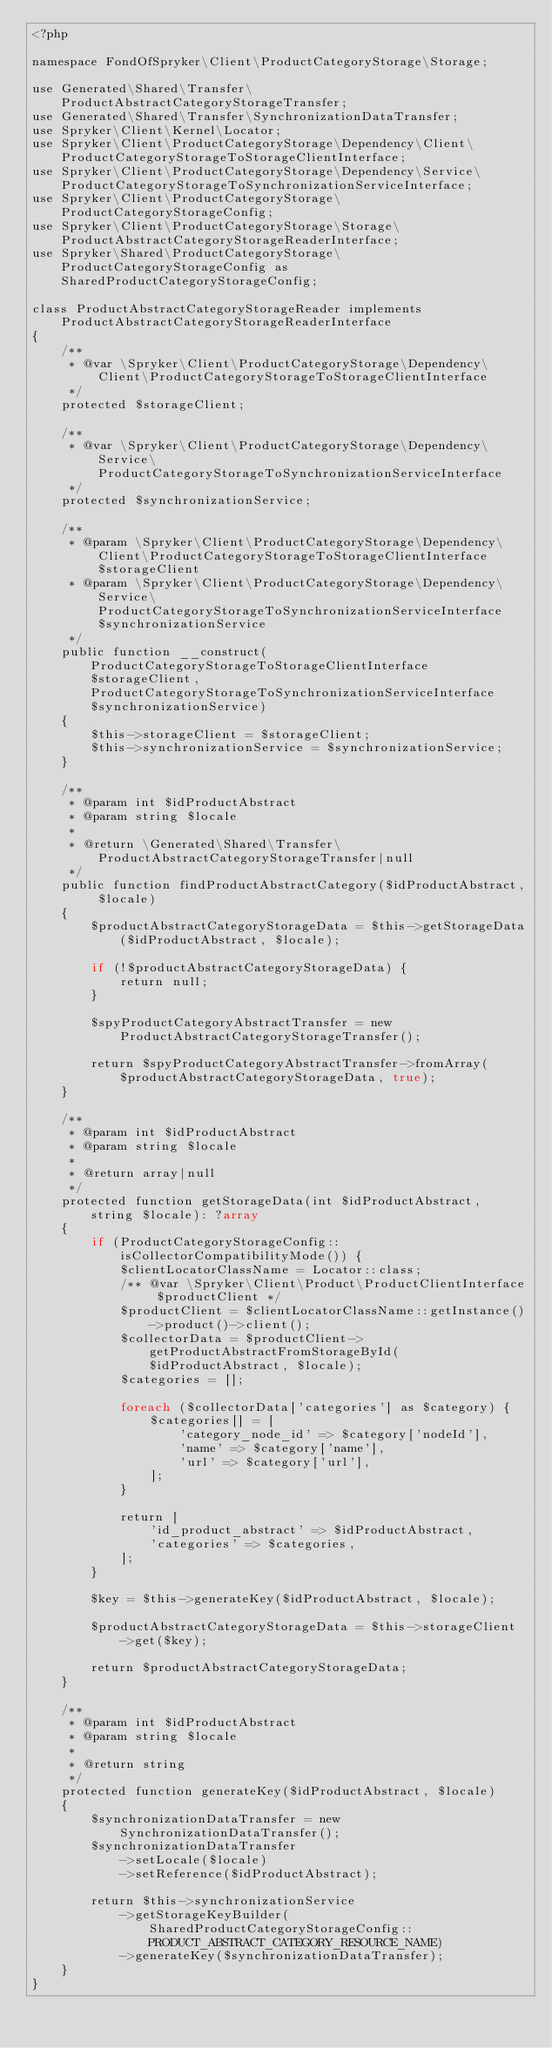Convert code to text. <code><loc_0><loc_0><loc_500><loc_500><_PHP_><?php

namespace FondOfSpryker\Client\ProductCategoryStorage\Storage;

use Generated\Shared\Transfer\ProductAbstractCategoryStorageTransfer;
use Generated\Shared\Transfer\SynchronizationDataTransfer;
use Spryker\Client\Kernel\Locator;
use Spryker\Client\ProductCategoryStorage\Dependency\Client\ProductCategoryStorageToStorageClientInterface;
use Spryker\Client\ProductCategoryStorage\Dependency\Service\ProductCategoryStorageToSynchronizationServiceInterface;
use Spryker\Client\ProductCategoryStorage\ProductCategoryStorageConfig;
use Spryker\Client\ProductCategoryStorage\Storage\ProductAbstractCategoryStorageReaderInterface;
use Spryker\Shared\ProductCategoryStorage\ProductCategoryStorageConfig as SharedProductCategoryStorageConfig;

class ProductAbstractCategoryStorageReader implements ProductAbstractCategoryStorageReaderInterface
{
    /**
     * @var \Spryker\Client\ProductCategoryStorage\Dependency\Client\ProductCategoryStorageToStorageClientInterface
     */
    protected $storageClient;

    /**
     * @var \Spryker\Client\ProductCategoryStorage\Dependency\Service\ProductCategoryStorageToSynchronizationServiceInterface
     */
    protected $synchronizationService;

    /**
     * @param \Spryker\Client\ProductCategoryStorage\Dependency\Client\ProductCategoryStorageToStorageClientInterface $storageClient
     * @param \Spryker\Client\ProductCategoryStorage\Dependency\Service\ProductCategoryStorageToSynchronizationServiceInterface $synchronizationService
     */
    public function __construct(ProductCategoryStorageToStorageClientInterface $storageClient, ProductCategoryStorageToSynchronizationServiceInterface $synchronizationService)
    {
        $this->storageClient = $storageClient;
        $this->synchronizationService = $synchronizationService;
    }

    /**
     * @param int $idProductAbstract
     * @param string $locale
     *
     * @return \Generated\Shared\Transfer\ProductAbstractCategoryStorageTransfer|null
     */
    public function findProductAbstractCategory($idProductAbstract, $locale)
    {
        $productAbstractCategoryStorageData = $this->getStorageData($idProductAbstract, $locale);

        if (!$productAbstractCategoryStorageData) {
            return null;
        }

        $spyProductCategoryAbstractTransfer = new ProductAbstractCategoryStorageTransfer();

        return $spyProductCategoryAbstractTransfer->fromArray($productAbstractCategoryStorageData, true);
    }

    /**
     * @param int $idProductAbstract
     * @param string $locale
     *
     * @return array|null
     */
    protected function getStorageData(int $idProductAbstract, string $locale): ?array
    {
        if (ProductCategoryStorageConfig::isCollectorCompatibilityMode()) {
            $clientLocatorClassName = Locator::class;
            /** @var \Spryker\Client\Product\ProductClientInterface $productClient */
            $productClient = $clientLocatorClassName::getInstance()->product()->client();
            $collectorData = $productClient->getProductAbstractFromStorageById($idProductAbstract, $locale);
            $categories = [];

            foreach ($collectorData['categories'] as $category) {
                $categories[] = [
                    'category_node_id' => $category['nodeId'],
                    'name' => $category['name'],
                    'url' => $category['url'],
                ];
            }

            return [
                'id_product_abstract' => $idProductAbstract,
                'categories' => $categories,
            ];
        }

        $key = $this->generateKey($idProductAbstract, $locale);

        $productAbstractCategoryStorageData = $this->storageClient->get($key);

        return $productAbstractCategoryStorageData;
    }

    /**
     * @param int $idProductAbstract
     * @param string $locale
     *
     * @return string
     */
    protected function generateKey($idProductAbstract, $locale)
    {
        $synchronizationDataTransfer = new SynchronizationDataTransfer();
        $synchronizationDataTransfer
            ->setLocale($locale)
            ->setReference($idProductAbstract);

        return $this->synchronizationService
            ->getStorageKeyBuilder(SharedProductCategoryStorageConfig::PRODUCT_ABSTRACT_CATEGORY_RESOURCE_NAME)
            ->generateKey($synchronizationDataTransfer);
    }
}
</code> 